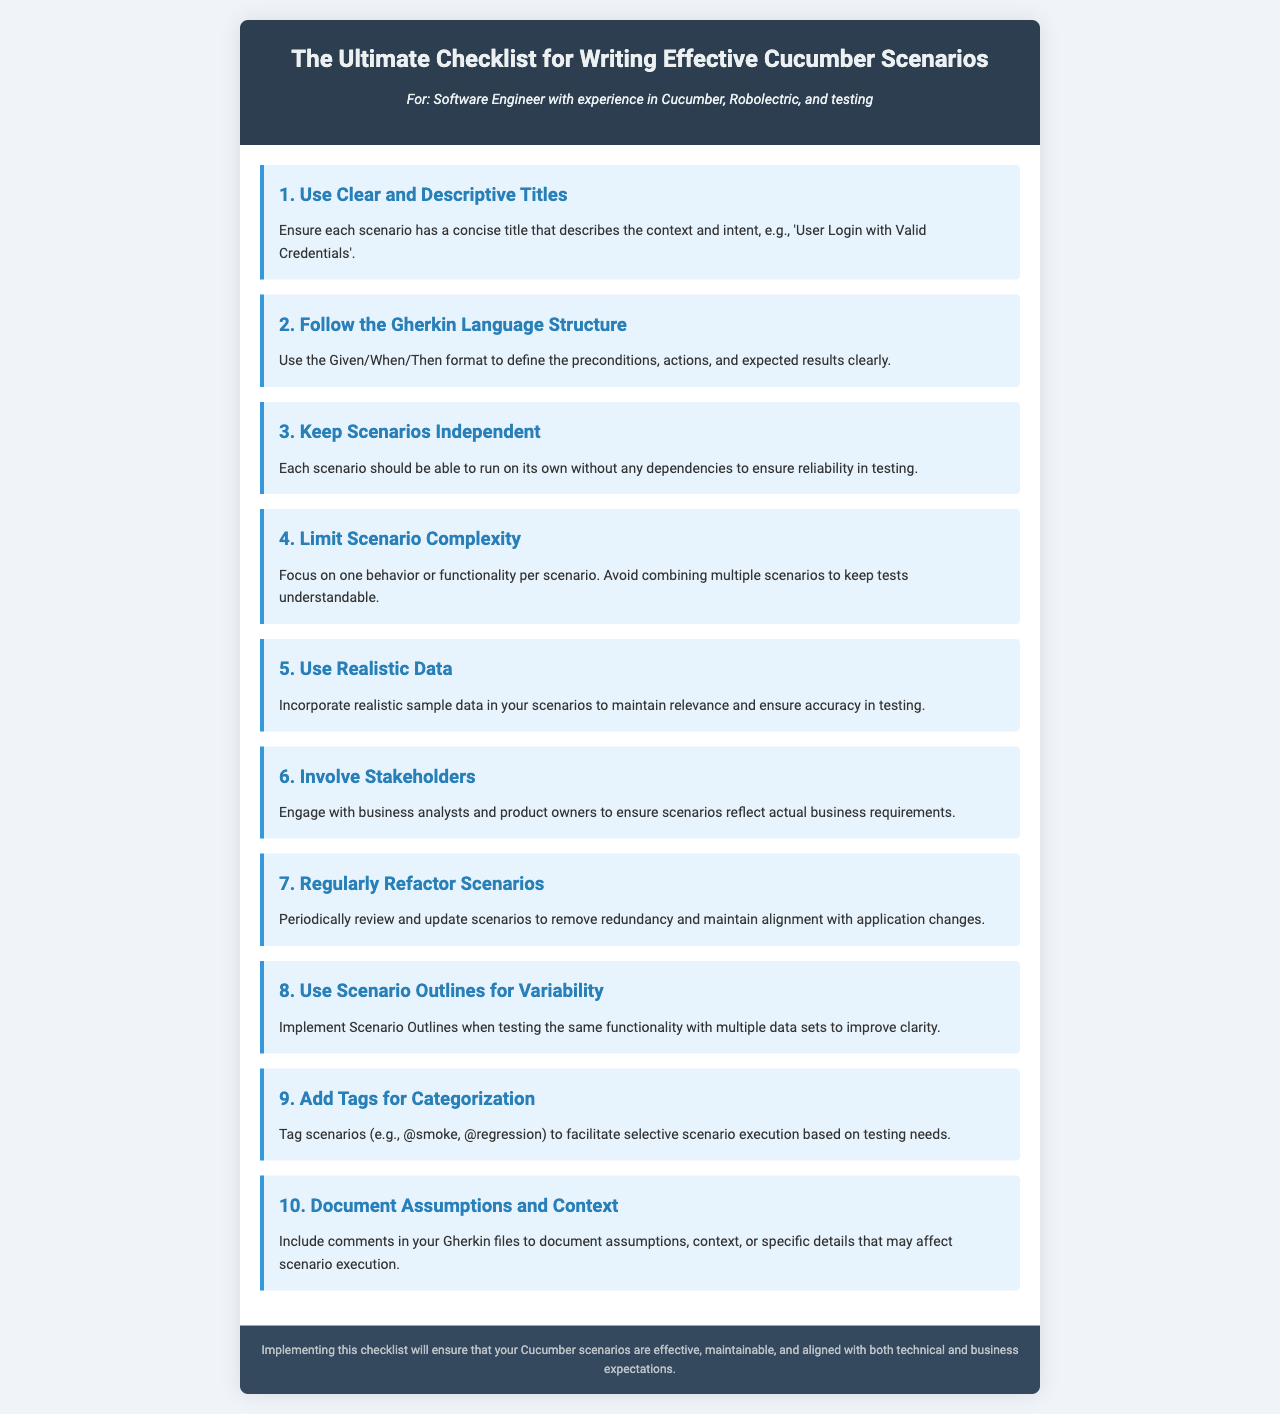What is the title of the brochure? The title is located in the header section and serves as the main subject of the document.
Answer: The Ultimate Checklist for Writing Effective Cucumber Scenarios Who is the intended audience for this brochure? The intended audience is specified in the persona section beneath the title of the brochure.
Answer: Software Engineer with experience in Cucumber, Robolectric, and testing What is the first item on the checklist? The first item is the top point of the checklist provided in the document.
Answer: Use Clear and Descriptive Titles How many items are listed in the checklist? The total count of checklist items is derived from counting each checklist item provided.
Answer: 10 What methodology should be followed in the scenarios? The methodology is specified as a structured approach for writing scenarios.
Answer: Gherkin Language Structure What is the purpose of using Scenario Outlines? The purpose is explained in the context of testing within the checklist.
Answer: Variability What should be included in comments in Gherkin files? The specific content to be included is suggested in the document's last checklist item.
Answer: Assumptions and Context What does tagging scenarios help facilitate? The function of tagging in the context of scenario management is described in the document.
Answer: Selective scenario execution What does the footer state regarding the checklist? The footer summarizes the intended outcome of following the checklist.
Answer: Effective, maintainable, and aligned with both technical and business expectations 